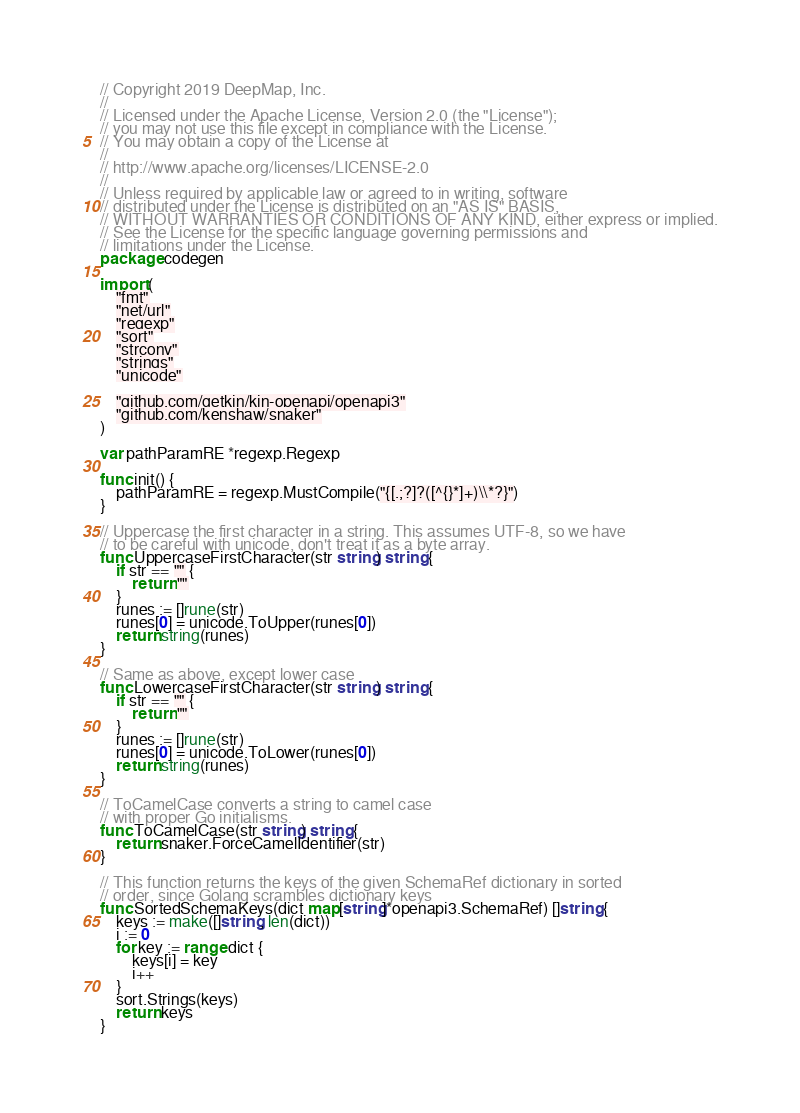Convert code to text. <code><loc_0><loc_0><loc_500><loc_500><_Go_>// Copyright 2019 DeepMap, Inc.
//
// Licensed under the Apache License, Version 2.0 (the "License");
// you may not use this file except in compliance with the License.
// You may obtain a copy of the License at
//
// http://www.apache.org/licenses/LICENSE-2.0
//
// Unless required by applicable law or agreed to in writing, software
// distributed under the License is distributed on an "AS IS" BASIS,
// WITHOUT WARRANTIES OR CONDITIONS OF ANY KIND, either express or implied.
// See the License for the specific language governing permissions and
// limitations under the License.
package codegen

import (
	"fmt"
	"net/url"
	"regexp"
	"sort"
	"strconv"
	"strings"
	"unicode"

	"github.com/getkin/kin-openapi/openapi3"
	"github.com/kenshaw/snaker"
)

var pathParamRE *regexp.Regexp

func init() {
	pathParamRE = regexp.MustCompile("{[.;?]?([^{}*]+)\\*?}")
}

// Uppercase the first character in a string. This assumes UTF-8, so we have
// to be careful with unicode, don't treat it as a byte array.
func UppercaseFirstCharacter(str string) string {
	if str == "" {
		return ""
	}
	runes := []rune(str)
	runes[0] = unicode.ToUpper(runes[0])
	return string(runes)
}

// Same as above, except lower case
func LowercaseFirstCharacter(str string) string {
	if str == "" {
		return ""
	}
	runes := []rune(str)
	runes[0] = unicode.ToLower(runes[0])
	return string(runes)
}

// ToCamelCase converts a string to camel case
// with proper Go initialisms.
func ToCamelCase(str string) string {
	return snaker.ForceCamelIdentifier(str)
}

// This function returns the keys of the given SchemaRef dictionary in sorted
// order, since Golang scrambles dictionary keys
func SortedSchemaKeys(dict map[string]*openapi3.SchemaRef) []string {
	keys := make([]string, len(dict))
	i := 0
	for key := range dict {
		keys[i] = key
		i++
	}
	sort.Strings(keys)
	return keys
}
</code> 